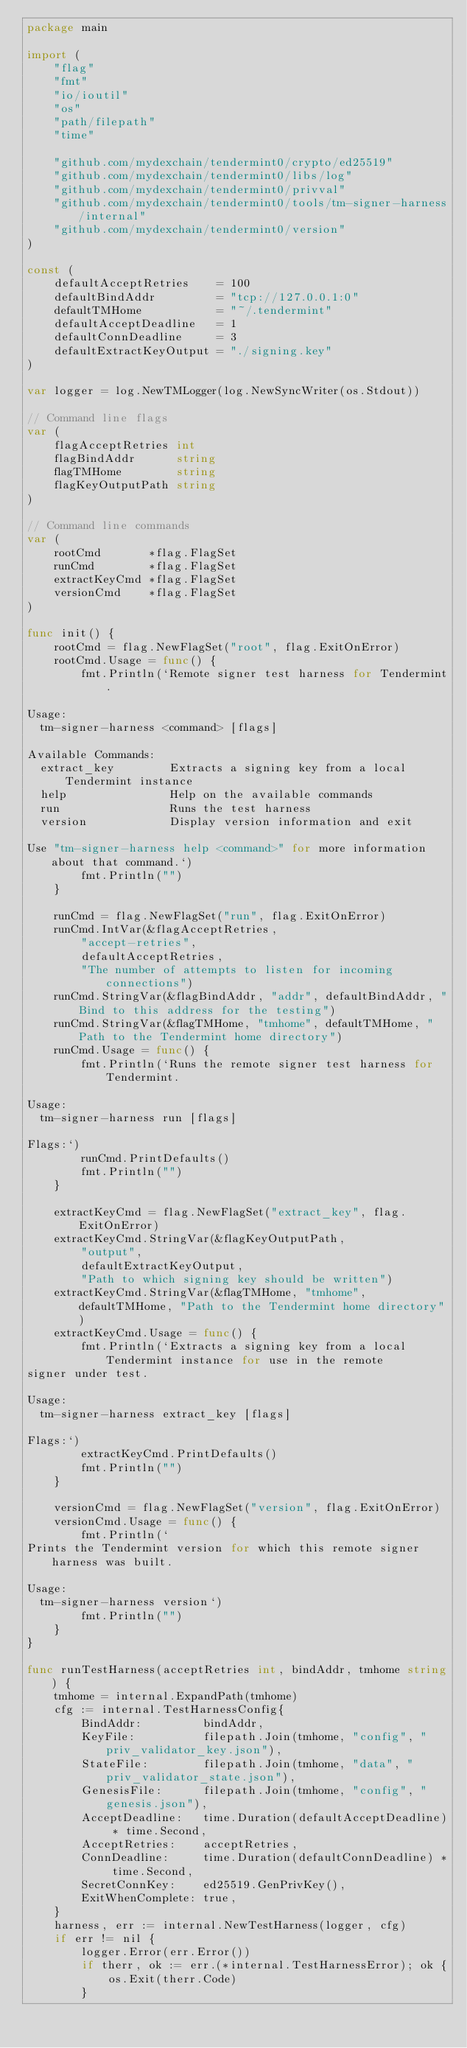Convert code to text. <code><loc_0><loc_0><loc_500><loc_500><_Go_>package main

import (
	"flag"
	"fmt"
	"io/ioutil"
	"os"
	"path/filepath"
	"time"

	"github.com/mydexchain/tendermint0/crypto/ed25519"
	"github.com/mydexchain/tendermint0/libs/log"
	"github.com/mydexchain/tendermint0/privval"
	"github.com/mydexchain/tendermint0/tools/tm-signer-harness/internal"
	"github.com/mydexchain/tendermint0/version"
)

const (
	defaultAcceptRetries    = 100
	defaultBindAddr         = "tcp://127.0.0.1:0"
	defaultTMHome           = "~/.tendermint"
	defaultAcceptDeadline   = 1
	defaultConnDeadline     = 3
	defaultExtractKeyOutput = "./signing.key"
)

var logger = log.NewTMLogger(log.NewSyncWriter(os.Stdout))

// Command line flags
var (
	flagAcceptRetries int
	flagBindAddr      string
	flagTMHome        string
	flagKeyOutputPath string
)

// Command line commands
var (
	rootCmd       *flag.FlagSet
	runCmd        *flag.FlagSet
	extractKeyCmd *flag.FlagSet
	versionCmd    *flag.FlagSet
)

func init() {
	rootCmd = flag.NewFlagSet("root", flag.ExitOnError)
	rootCmd.Usage = func() {
		fmt.Println(`Remote signer test harness for Tendermint.

Usage:
  tm-signer-harness <command> [flags]

Available Commands:
  extract_key        Extracts a signing key from a local Tendermint instance
  help               Help on the available commands
  run                Runs the test harness
  version            Display version information and exit

Use "tm-signer-harness help <command>" for more information about that command.`)
		fmt.Println("")
	}

	runCmd = flag.NewFlagSet("run", flag.ExitOnError)
	runCmd.IntVar(&flagAcceptRetries,
		"accept-retries",
		defaultAcceptRetries,
		"The number of attempts to listen for incoming connections")
	runCmd.StringVar(&flagBindAddr, "addr", defaultBindAddr, "Bind to this address for the testing")
	runCmd.StringVar(&flagTMHome, "tmhome", defaultTMHome, "Path to the Tendermint home directory")
	runCmd.Usage = func() {
		fmt.Println(`Runs the remote signer test harness for Tendermint.

Usage:
  tm-signer-harness run [flags]

Flags:`)
		runCmd.PrintDefaults()
		fmt.Println("")
	}

	extractKeyCmd = flag.NewFlagSet("extract_key", flag.ExitOnError)
	extractKeyCmd.StringVar(&flagKeyOutputPath,
		"output",
		defaultExtractKeyOutput,
		"Path to which signing key should be written")
	extractKeyCmd.StringVar(&flagTMHome, "tmhome", defaultTMHome, "Path to the Tendermint home directory")
	extractKeyCmd.Usage = func() {
		fmt.Println(`Extracts a signing key from a local Tendermint instance for use in the remote
signer under test.

Usage:
  tm-signer-harness extract_key [flags]

Flags:`)
		extractKeyCmd.PrintDefaults()
		fmt.Println("")
	}

	versionCmd = flag.NewFlagSet("version", flag.ExitOnError)
	versionCmd.Usage = func() {
		fmt.Println(`
Prints the Tendermint version for which this remote signer harness was built.

Usage:
  tm-signer-harness version`)
		fmt.Println("")
	}
}

func runTestHarness(acceptRetries int, bindAddr, tmhome string) {
	tmhome = internal.ExpandPath(tmhome)
	cfg := internal.TestHarnessConfig{
		BindAddr:         bindAddr,
		KeyFile:          filepath.Join(tmhome, "config", "priv_validator_key.json"),
		StateFile:        filepath.Join(tmhome, "data", "priv_validator_state.json"),
		GenesisFile:      filepath.Join(tmhome, "config", "genesis.json"),
		AcceptDeadline:   time.Duration(defaultAcceptDeadline) * time.Second,
		AcceptRetries:    acceptRetries,
		ConnDeadline:     time.Duration(defaultConnDeadline) * time.Second,
		SecretConnKey:    ed25519.GenPrivKey(),
		ExitWhenComplete: true,
	}
	harness, err := internal.NewTestHarness(logger, cfg)
	if err != nil {
		logger.Error(err.Error())
		if therr, ok := err.(*internal.TestHarnessError); ok {
			os.Exit(therr.Code)
		}</code> 